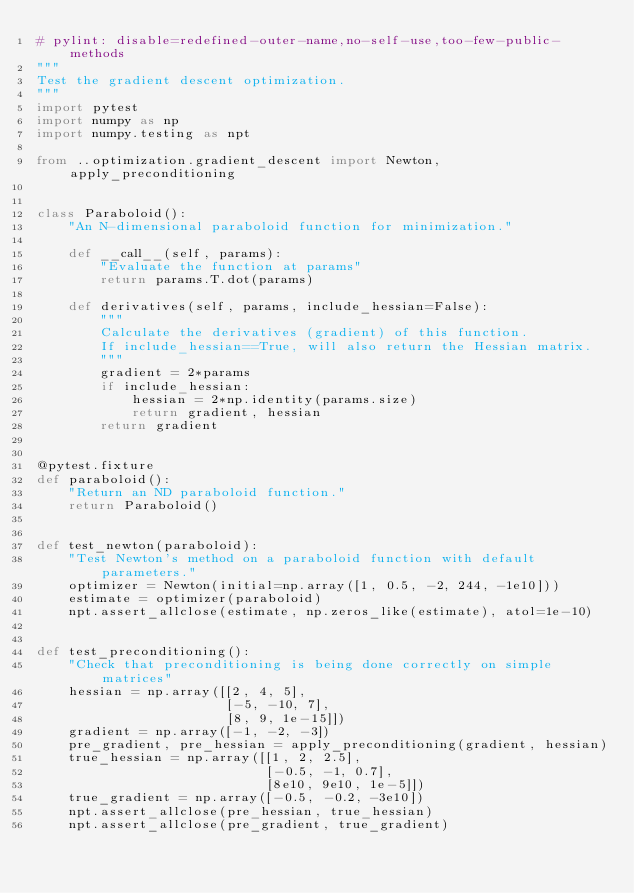<code> <loc_0><loc_0><loc_500><loc_500><_Python_># pylint: disable=redefined-outer-name,no-self-use,too-few-public-methods
"""
Test the gradient descent optimization.
"""
import pytest
import numpy as np
import numpy.testing as npt

from ..optimization.gradient_descent import Newton, apply_preconditioning


class Paraboloid():
    "An N-dimensional paraboloid function for minimization."

    def __call__(self, params):
        "Evaluate the function at params"
        return params.T.dot(params)

    def derivatives(self, params, include_hessian=False):
        """
        Calculate the derivatives (gradient) of this function.
        If include_hessian==True, will also return the Hessian matrix.
        """
        gradient = 2*params
        if include_hessian:
            hessian = 2*np.identity(params.size)
            return gradient, hessian
        return gradient


@pytest.fixture
def paraboloid():
    "Return an ND paraboloid function."
    return Paraboloid()


def test_newton(paraboloid):
    "Test Newton's method on a paraboloid function with default parameters."
    optimizer = Newton(initial=np.array([1, 0.5, -2, 244, -1e10]))
    estimate = optimizer(paraboloid)
    npt.assert_allclose(estimate, np.zeros_like(estimate), atol=1e-10)


def test_preconditioning():
    "Check that preconditioning is being done correctly on simple matrices"
    hessian = np.array([[2, 4, 5],
                        [-5, -10, 7],
                        [8, 9, 1e-15]])
    gradient = np.array([-1, -2, -3])
    pre_gradient, pre_hessian = apply_preconditioning(gradient, hessian)
    true_hessian = np.array([[1, 2, 2.5],
                             [-0.5, -1, 0.7],
                             [8e10, 9e10, 1e-5]])
    true_gradient = np.array([-0.5, -0.2, -3e10])
    npt.assert_allclose(pre_hessian, true_hessian)
    npt.assert_allclose(pre_gradient, true_gradient)
</code> 